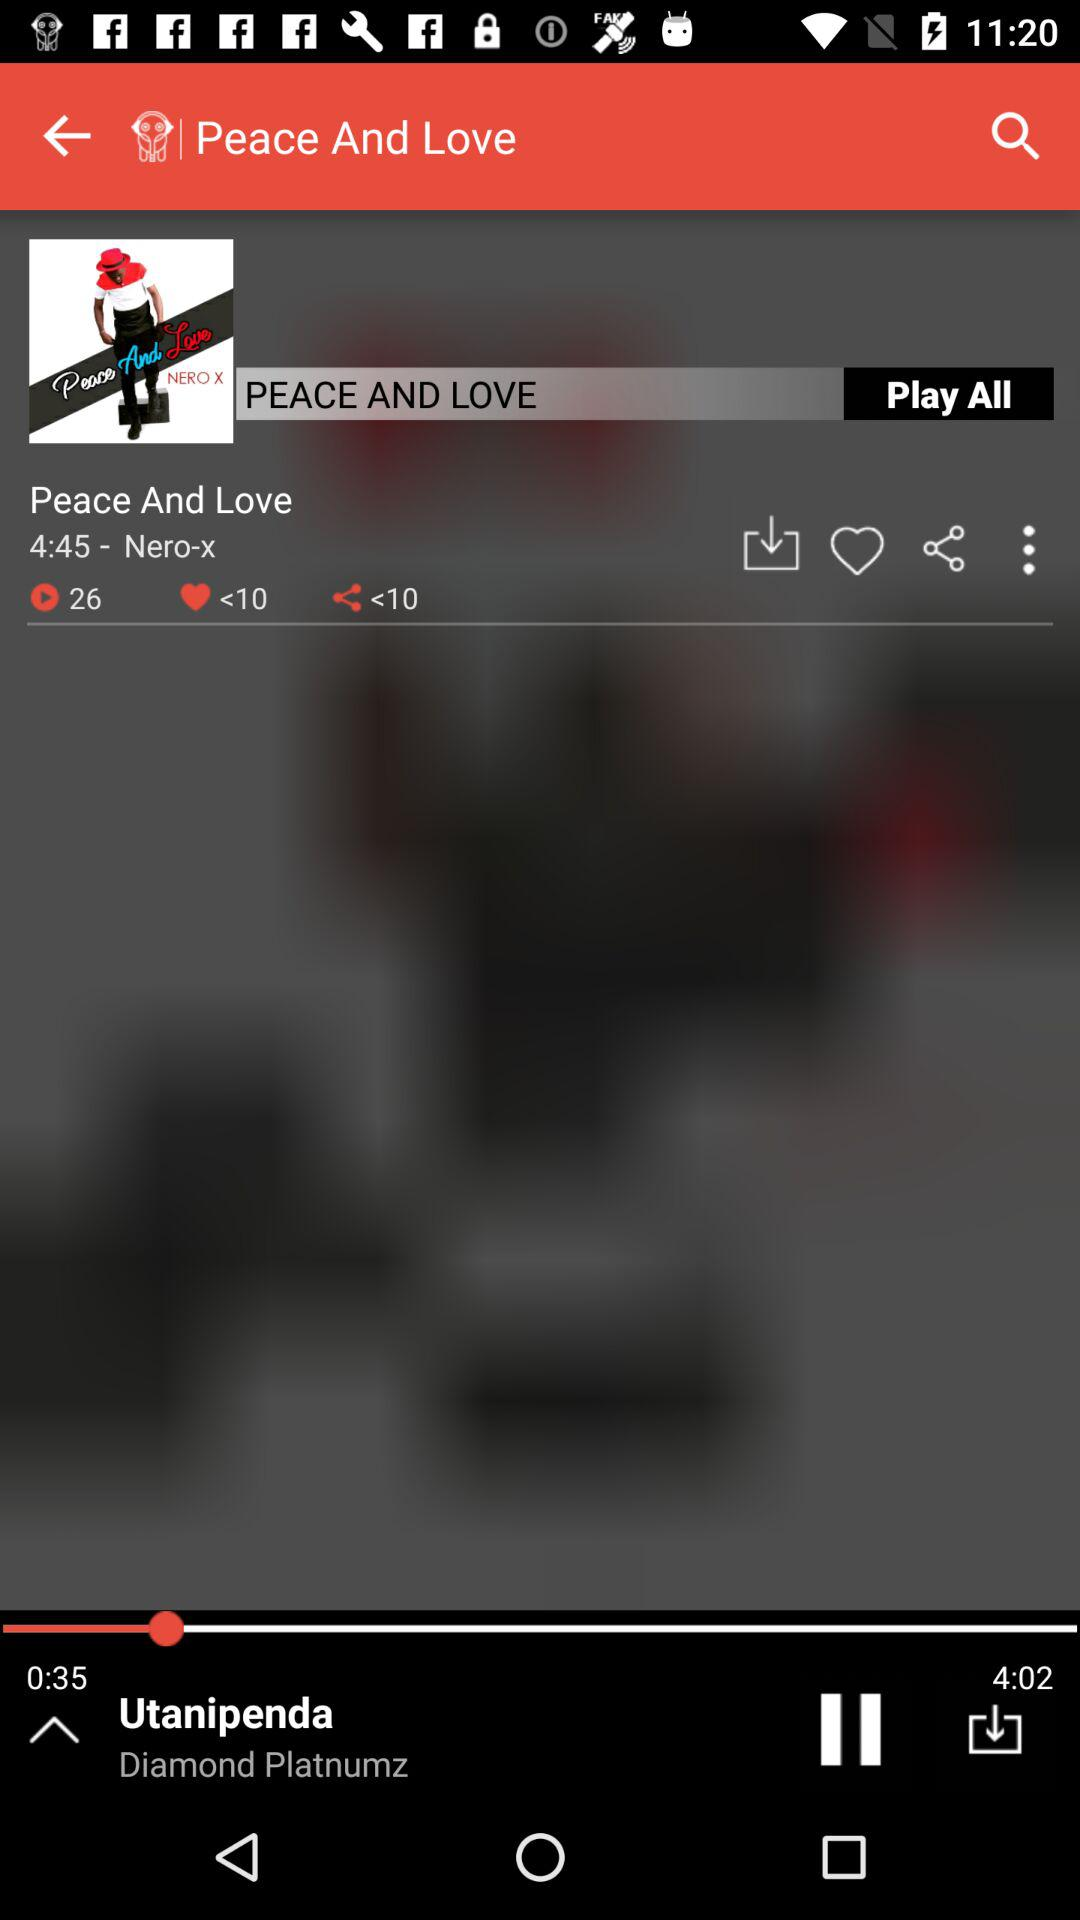How many total songs are there in the album? There are total 26 songs in the album. 